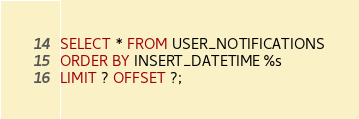Convert code to text. <code><loc_0><loc_0><loc_500><loc_500><_SQL_>SELECT * FROM USER_NOTIFICATIONS
ORDER BY INSERT_DATETIME %s
LIMIT ? OFFSET ?;
</code> 